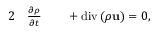Convert formula to latex. <formula><loc_0><loc_0><loc_500><loc_500>\begin{array} { r l r l } { 2 } & \frac { \partial \rho } { \partial t } } & + d i v \left ( \rho u \right ) = 0 , } \end{array}</formula> 